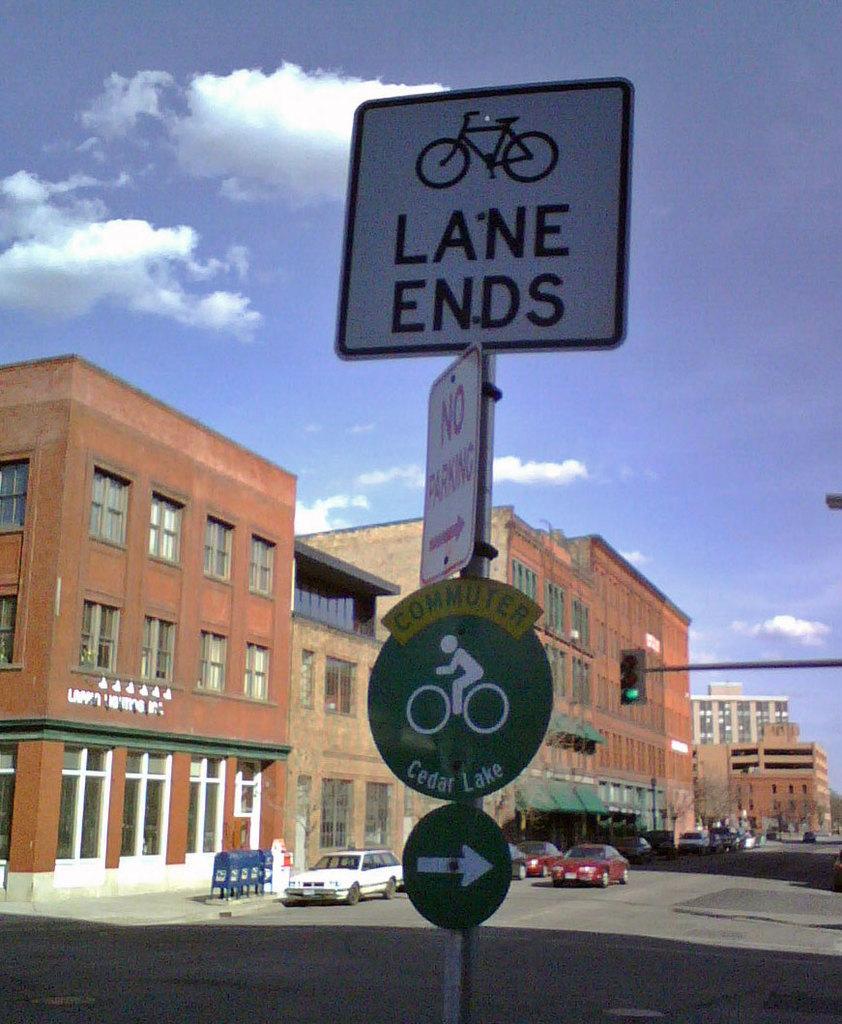What does the top sign say?
Provide a succinct answer. Lane ends. What does the second sign say?
Ensure brevity in your answer.  No parking. 